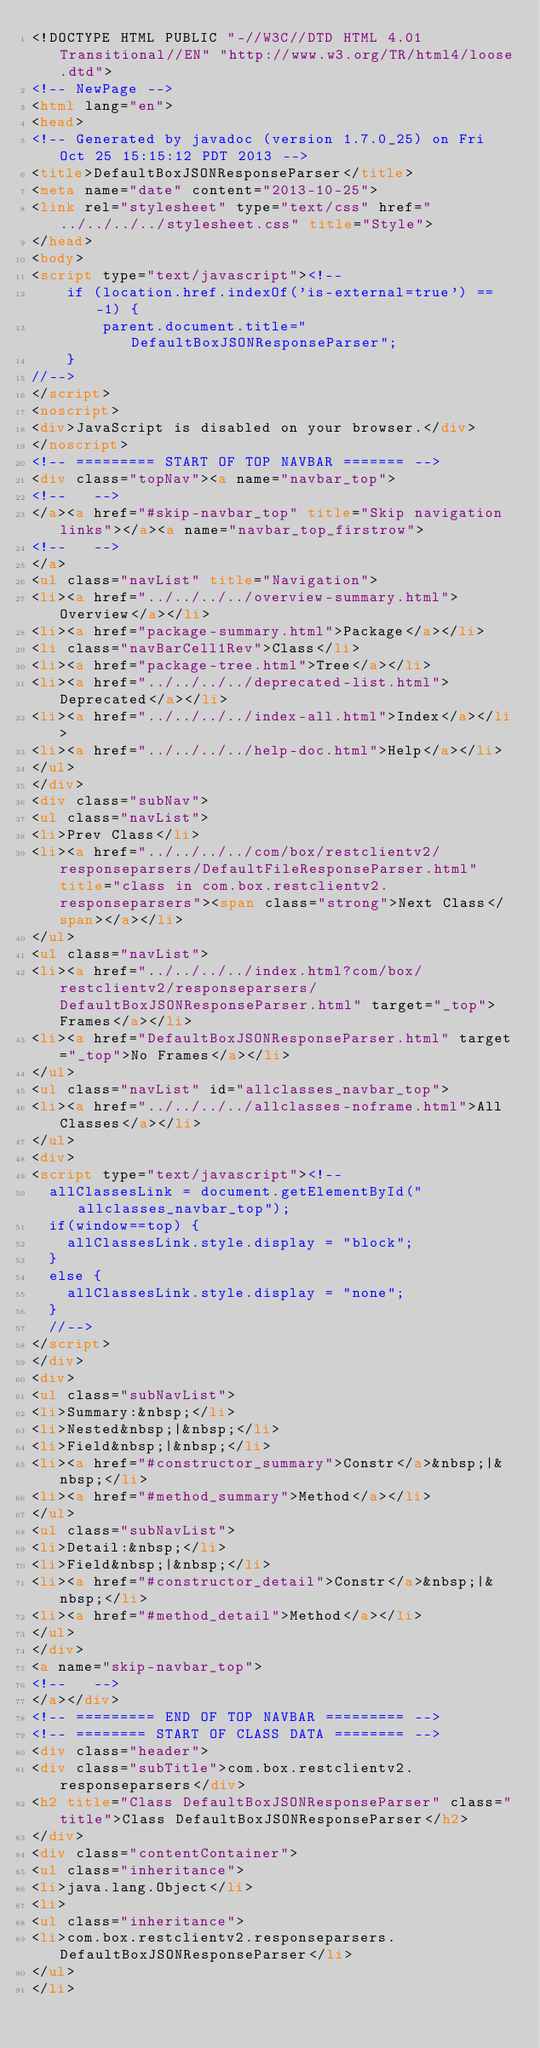<code> <loc_0><loc_0><loc_500><loc_500><_HTML_><!DOCTYPE HTML PUBLIC "-//W3C//DTD HTML 4.01 Transitional//EN" "http://www.w3.org/TR/html4/loose.dtd">
<!-- NewPage -->
<html lang="en">
<head>
<!-- Generated by javadoc (version 1.7.0_25) on Fri Oct 25 15:15:12 PDT 2013 -->
<title>DefaultBoxJSONResponseParser</title>
<meta name="date" content="2013-10-25">
<link rel="stylesheet" type="text/css" href="../../../../stylesheet.css" title="Style">
</head>
<body>
<script type="text/javascript"><!--
    if (location.href.indexOf('is-external=true') == -1) {
        parent.document.title="DefaultBoxJSONResponseParser";
    }
//-->
</script>
<noscript>
<div>JavaScript is disabled on your browser.</div>
</noscript>
<!-- ========= START OF TOP NAVBAR ======= -->
<div class="topNav"><a name="navbar_top">
<!--   -->
</a><a href="#skip-navbar_top" title="Skip navigation links"></a><a name="navbar_top_firstrow">
<!--   -->
</a>
<ul class="navList" title="Navigation">
<li><a href="../../../../overview-summary.html">Overview</a></li>
<li><a href="package-summary.html">Package</a></li>
<li class="navBarCell1Rev">Class</li>
<li><a href="package-tree.html">Tree</a></li>
<li><a href="../../../../deprecated-list.html">Deprecated</a></li>
<li><a href="../../../../index-all.html">Index</a></li>
<li><a href="../../../../help-doc.html">Help</a></li>
</ul>
</div>
<div class="subNav">
<ul class="navList">
<li>Prev Class</li>
<li><a href="../../../../com/box/restclientv2/responseparsers/DefaultFileResponseParser.html" title="class in com.box.restclientv2.responseparsers"><span class="strong">Next Class</span></a></li>
</ul>
<ul class="navList">
<li><a href="../../../../index.html?com/box/restclientv2/responseparsers/DefaultBoxJSONResponseParser.html" target="_top">Frames</a></li>
<li><a href="DefaultBoxJSONResponseParser.html" target="_top">No Frames</a></li>
</ul>
<ul class="navList" id="allclasses_navbar_top">
<li><a href="../../../../allclasses-noframe.html">All Classes</a></li>
</ul>
<div>
<script type="text/javascript"><!--
  allClassesLink = document.getElementById("allclasses_navbar_top");
  if(window==top) {
    allClassesLink.style.display = "block";
  }
  else {
    allClassesLink.style.display = "none";
  }
  //-->
</script>
</div>
<div>
<ul class="subNavList">
<li>Summary:&nbsp;</li>
<li>Nested&nbsp;|&nbsp;</li>
<li>Field&nbsp;|&nbsp;</li>
<li><a href="#constructor_summary">Constr</a>&nbsp;|&nbsp;</li>
<li><a href="#method_summary">Method</a></li>
</ul>
<ul class="subNavList">
<li>Detail:&nbsp;</li>
<li>Field&nbsp;|&nbsp;</li>
<li><a href="#constructor_detail">Constr</a>&nbsp;|&nbsp;</li>
<li><a href="#method_detail">Method</a></li>
</ul>
</div>
<a name="skip-navbar_top">
<!--   -->
</a></div>
<!-- ========= END OF TOP NAVBAR ========= -->
<!-- ======== START OF CLASS DATA ======== -->
<div class="header">
<div class="subTitle">com.box.restclientv2.responseparsers</div>
<h2 title="Class DefaultBoxJSONResponseParser" class="title">Class DefaultBoxJSONResponseParser</h2>
</div>
<div class="contentContainer">
<ul class="inheritance">
<li>java.lang.Object</li>
<li>
<ul class="inheritance">
<li>com.box.restclientv2.responseparsers.DefaultBoxJSONResponseParser</li>
</ul>
</li></code> 